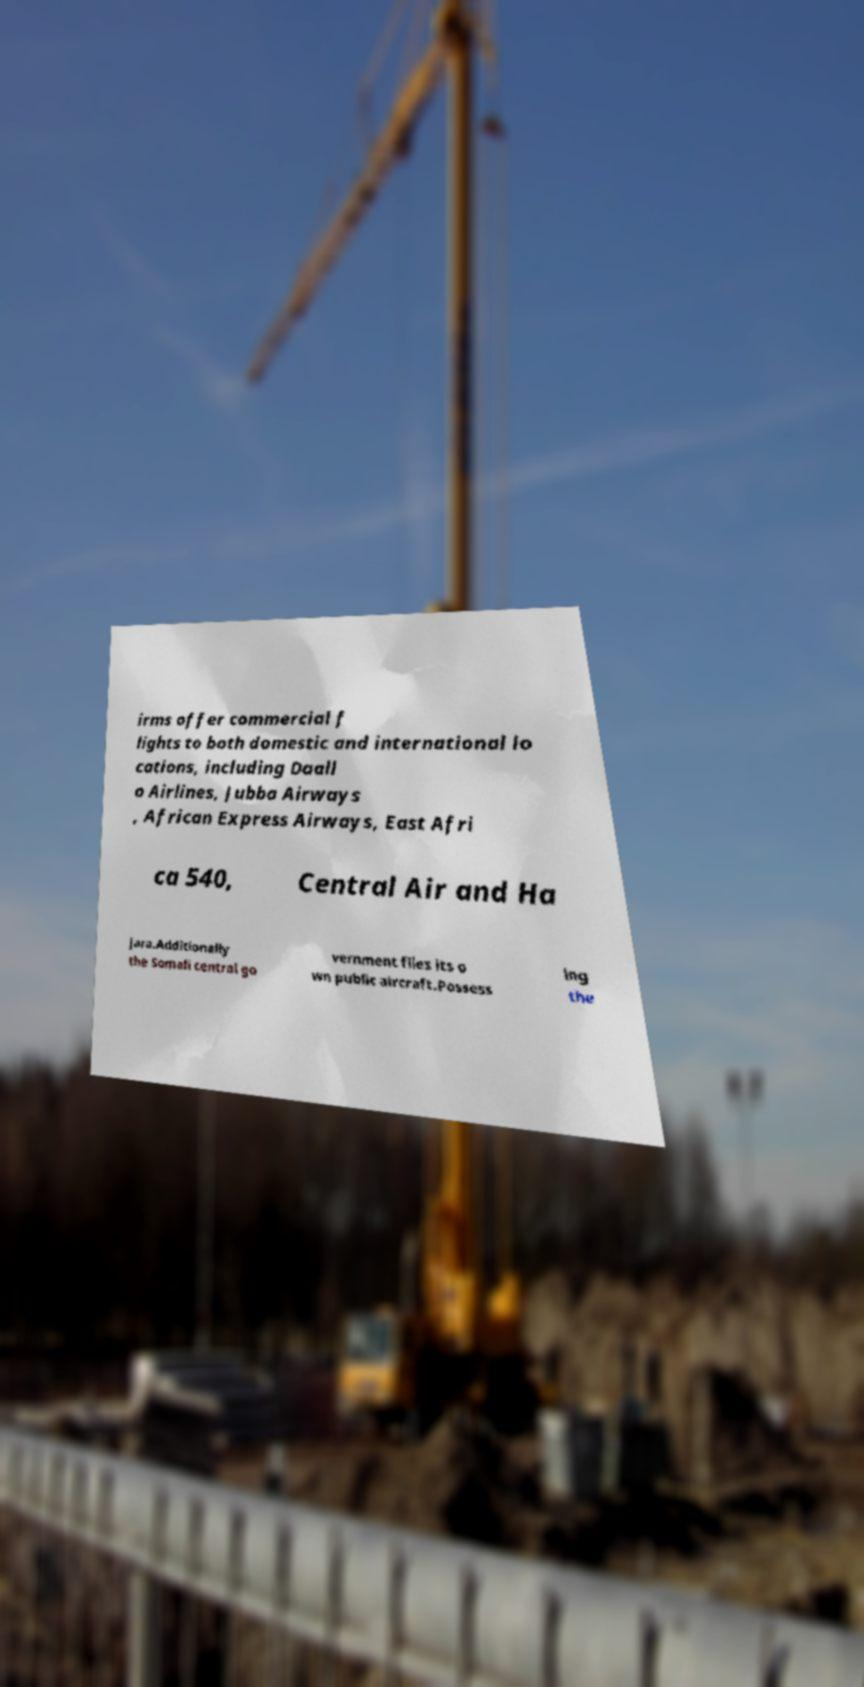Could you assist in decoding the text presented in this image and type it out clearly? irms offer commercial f lights to both domestic and international lo cations, including Daall o Airlines, Jubba Airways , African Express Airways, East Afri ca 540, Central Air and Ha jara.Additionally the Somali central go vernment flies its o wn public aircraft.Possess ing the 